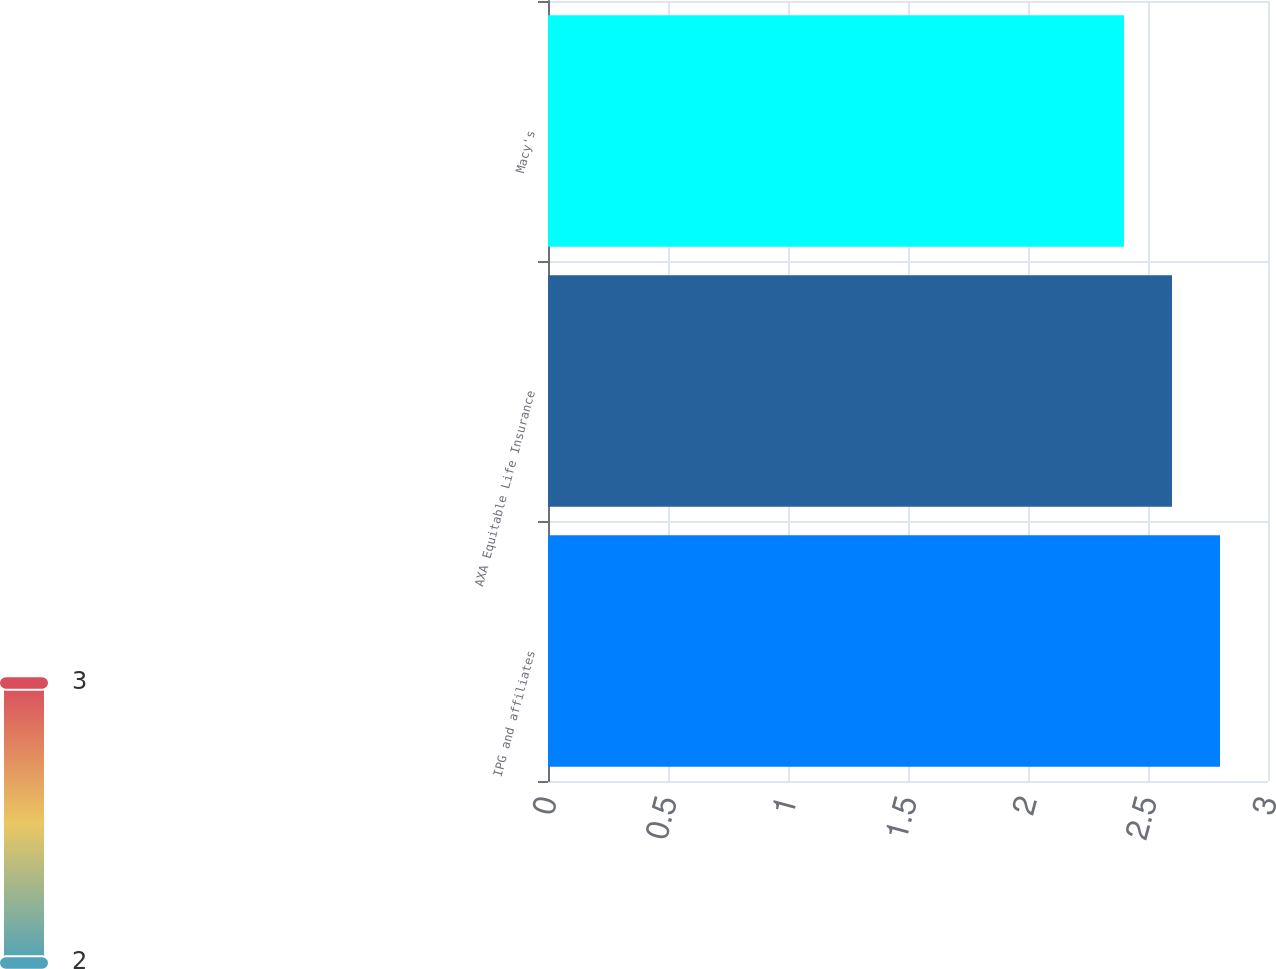<chart> <loc_0><loc_0><loc_500><loc_500><bar_chart><fcel>IPG and affiliates<fcel>AXA Equitable Life Insurance<fcel>Macy's<nl><fcel>2.8<fcel>2.6<fcel>2.4<nl></chart> 